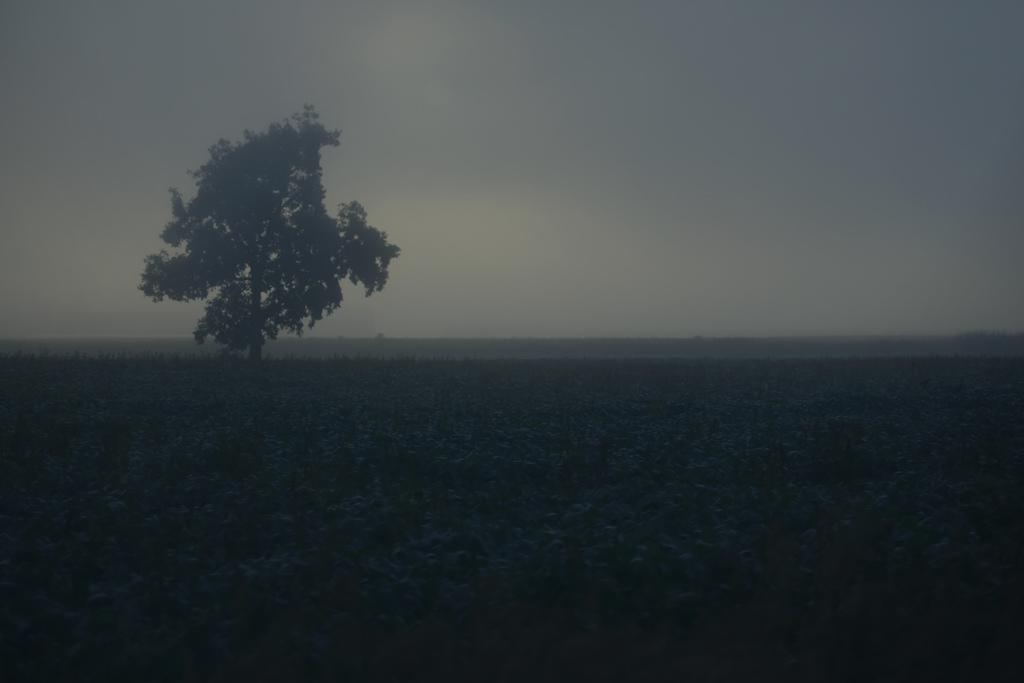What is the main object in the image? There is a tree in the image. What can be seen in the background of the image? The sky is visible in the background of the image. How is the sky described in the image? The color of the sky is described as white. How many horses are visible in the image? There are no horses present in the image. What type of sorting method is used for the chicken in the image? There is no chicken present in the image. 